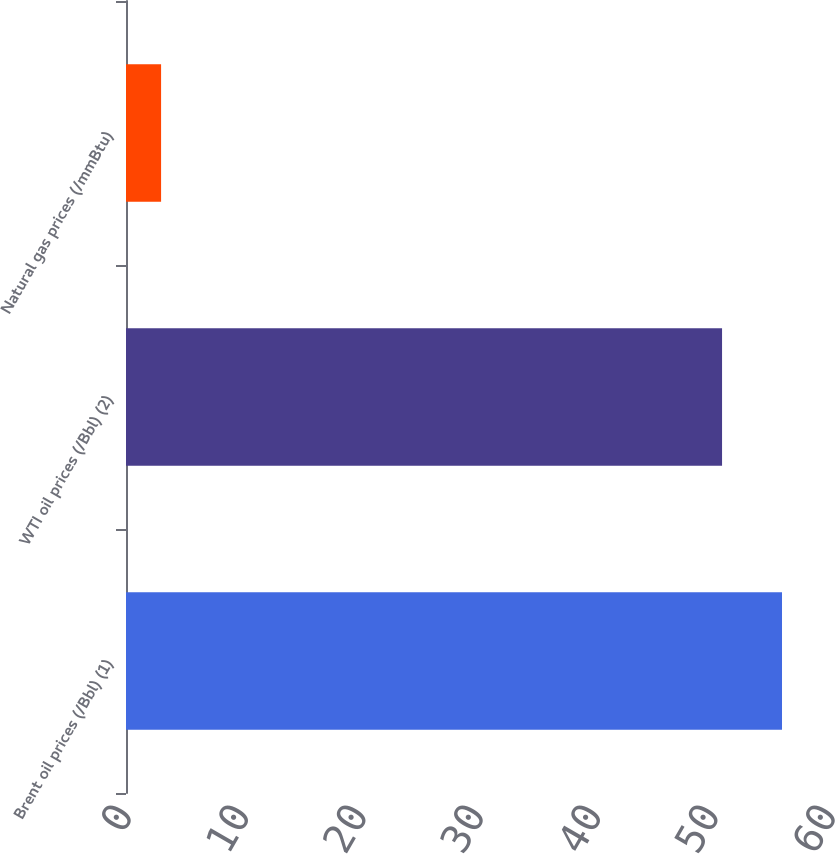Convert chart. <chart><loc_0><loc_0><loc_500><loc_500><bar_chart><fcel>Brent oil prices (/Bbl) (1)<fcel>WTI oil prices (/Bbl) (2)<fcel>Natural gas prices (/mmBtu)<nl><fcel>55.91<fcel>50.8<fcel>2.99<nl></chart> 